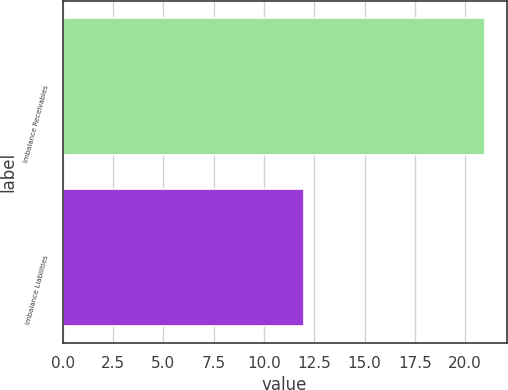Convert chart. <chart><loc_0><loc_0><loc_500><loc_500><bar_chart><fcel>Imbalance Receivables<fcel>Imbalance Liabilities<nl><fcel>21<fcel>12<nl></chart> 